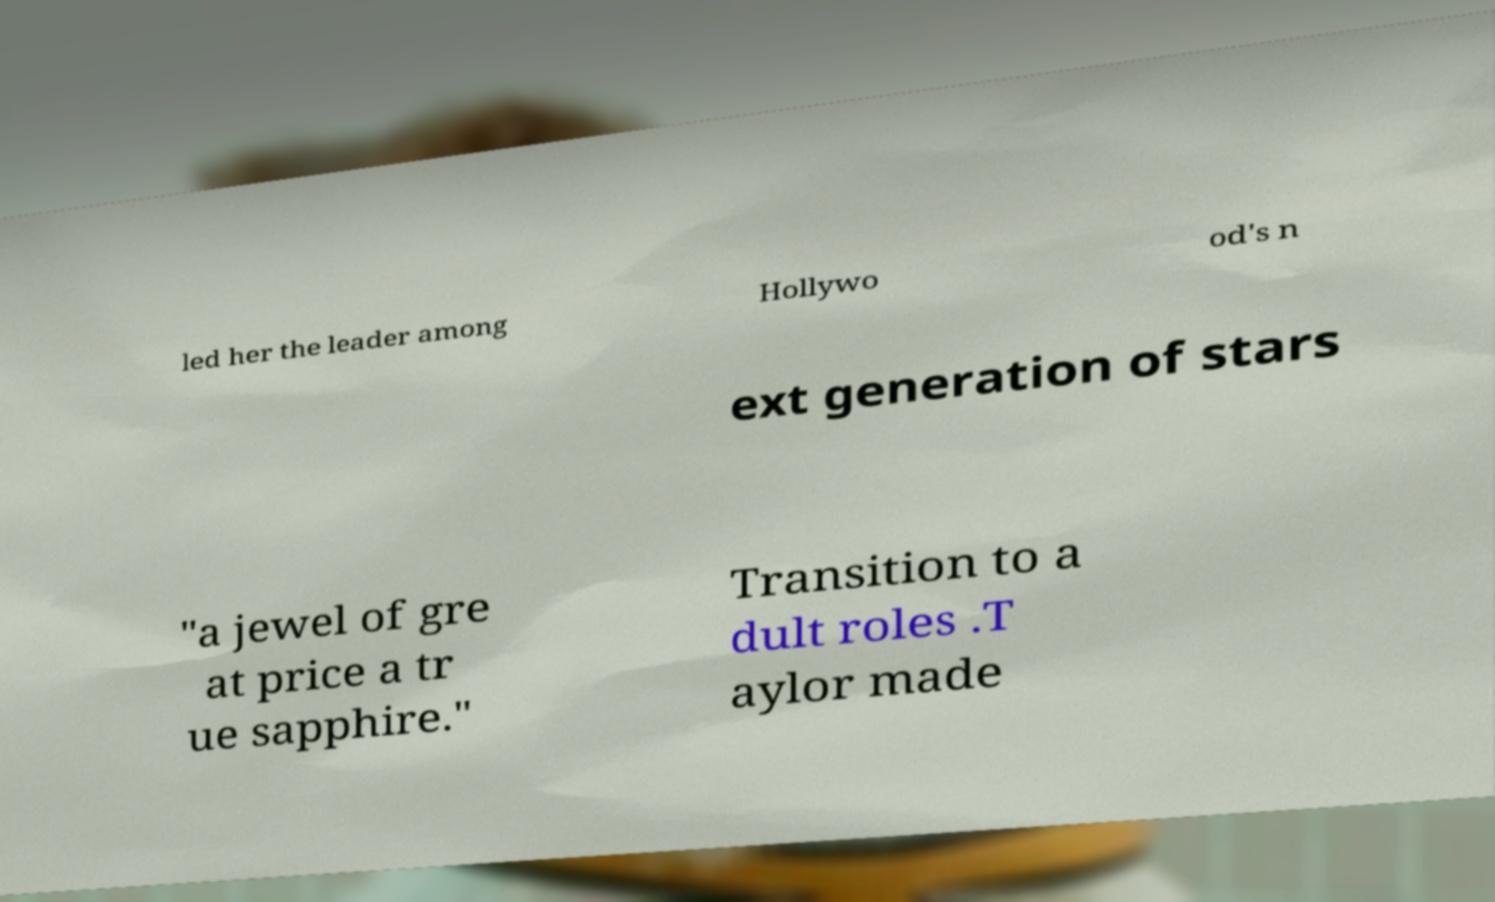Could you extract and type out the text from this image? led her the leader among Hollywo od's n ext generation of stars "a jewel of gre at price a tr ue sapphire." Transition to a dult roles .T aylor made 